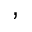<formula> <loc_0><loc_0><loc_500><loc_500>,</formula> 